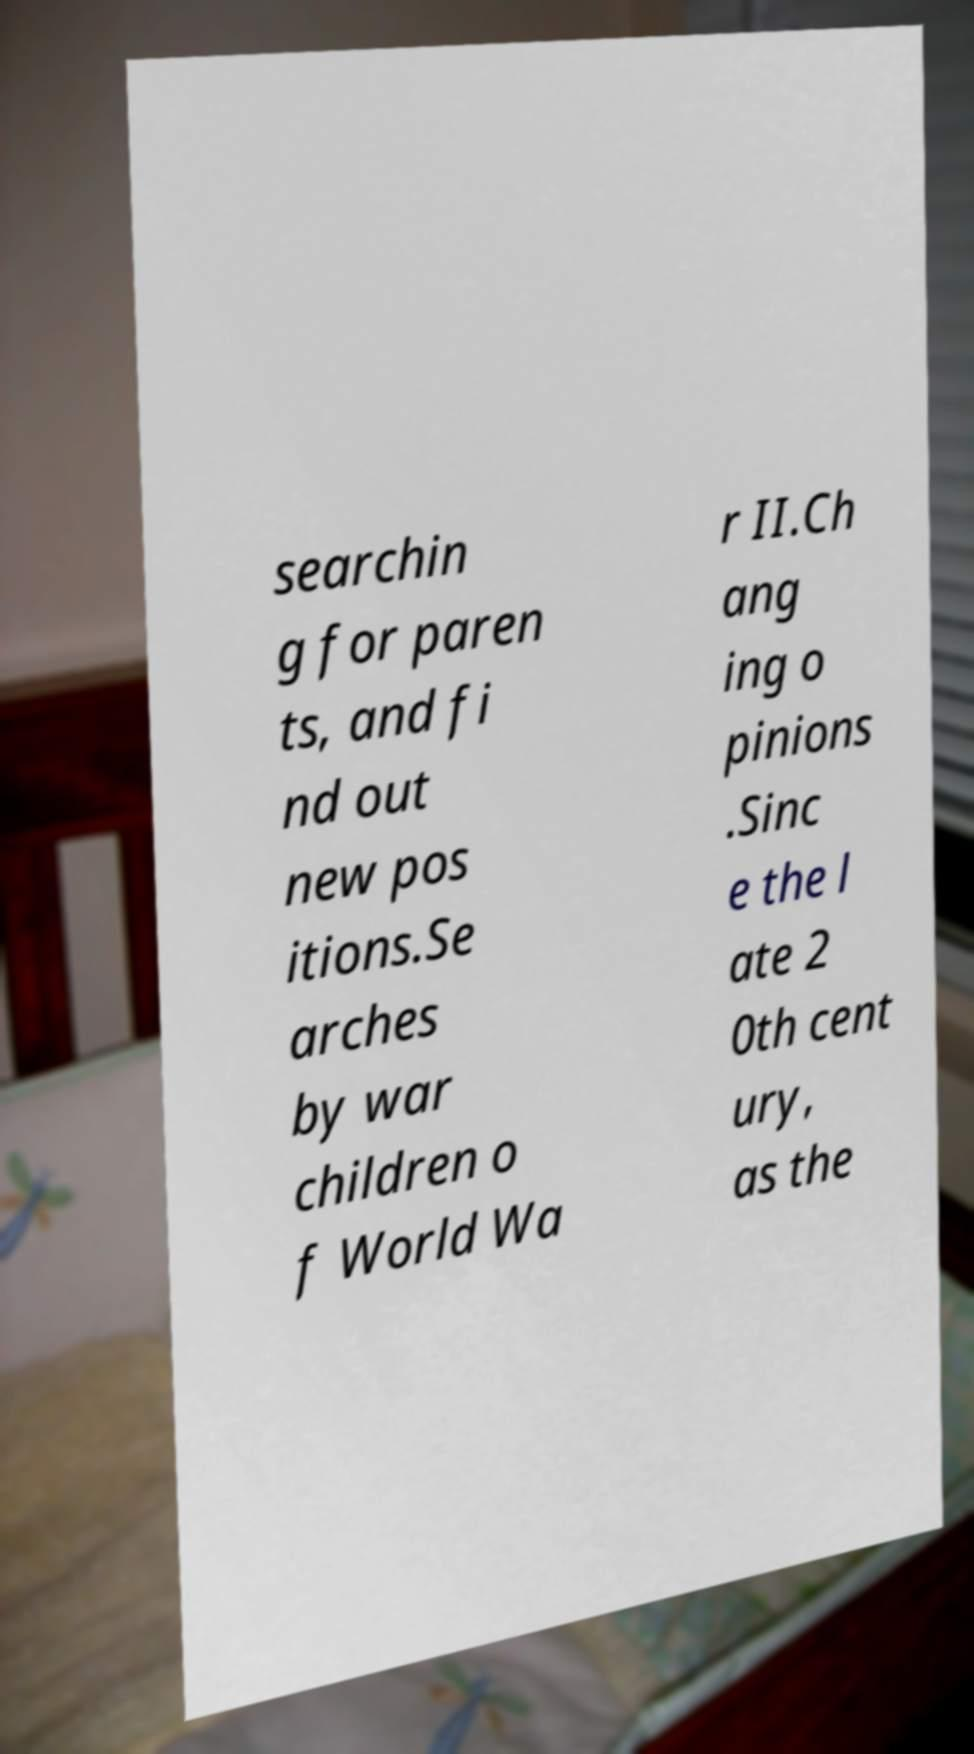Could you assist in decoding the text presented in this image and type it out clearly? searchin g for paren ts, and fi nd out new pos itions.Se arches by war children o f World Wa r II.Ch ang ing o pinions .Sinc e the l ate 2 0th cent ury, as the 